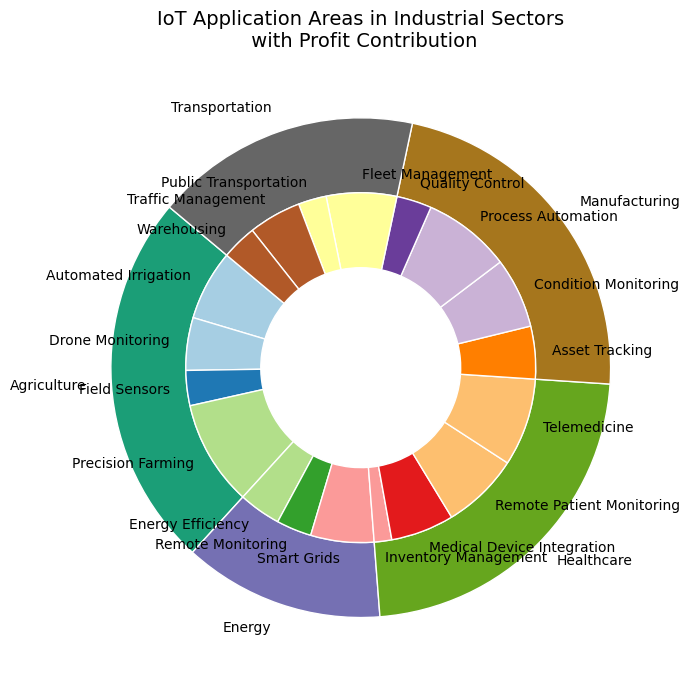Which sector has the highest profit contribution from IoT applications? By observing the outer pie chart, we can see that the agriculture sector has the largest slice, indicating the highest profit contribution.
Answer: Agriculture What are the top three IoT applications in the manufacturing sector by profit contribution? In the inner pie chart, the manufacturing sector's slices reveal that Process Automation has the highest contribution, followed by Condition Monitoring and Asset Tracking.
Answer: Process Automation, Condition Monitoring, Asset Tracking How does the profit contribution of Telemedicine in the healthcare sector compare to that in the transportation sector's Fleet Management? Telemedicine has a larger slice compared to Fleet Management in the inner pie chart, indicating a higher profit contribution.
Answer: Telemedicine has a higher profit contribution What is the total profit contribution of the Energy sector? Sum up the profit contributions of Smart Grids (18), Energy Efficiency (12), and Remote Monitoring (10) from the inner pie chart: 18 + 12 + 10 = 40.
Answer: 40 Which IoT application area contributes the least to the overall profit, and from which sector is it? In the inner pie chart, Inventory Management in the Healthcare sector has the smallest slice, indicating the least profit contribution.
Answer: Inventory Management, Healthcare Compare the total profit contributions of IoT applications in the Healthcare and Transportation sectors. Sum the subsector contributions for Healthcare (Remote Patient Monitoring 22, Medical Device Integration 18, Telemedicine 25, Inventory Management 5) to get 22 + 18 + 25 + 5 = 70. For Transportation, sum Fleet Management 20, Traffic Management 15, Warehousing 10, and Public Transportation 8 to get 20 + 15 + 10 + 8 = 53.
Answer: Healthcare contributes more than Transportation What is the combined profit contribution of Quality Control and Field Sensors? Add the profit contributions of Quality Control (10) from Manufacturing and Field Sensors (10) from Agriculture: 10 + 10 = 20.
Answer: 20 Which sector shows the highest diversity in IoT application areas based on the number of subsectors represented? The Healthcare sector has four different subsectors as represented in the inner pie chart, which is more than any other sector.
Answer: Healthcare Among Drone Monitoring and Condition Monitoring, which application area has a higher profit contribution, and by how much? Drone Monitoring in Agriculture contributes 15, while Condition Monitoring in Manufacturing contributes 20 according to the inner pie chart. The difference is 20 - 15 = 5.
Answer: Condition Monitoring by 5 Is the profit contribution of Asset Tracking in Manufacturing greater or less than the combined profit of Public Transportation and Warehousing in Transportation? Asset Tracking in Manufacturing is 15, while Public Transportation and Warehousing in Transportation are 8 and 10, respectively. The combined profit is 8 + 10 = 18, which is higher than 15.
Answer: Less 